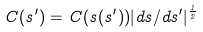Convert formula to latex. <formula><loc_0><loc_0><loc_500><loc_500>C ( s ^ { \prime } ) = C ( s ( s ^ { \prime } ) ) | d s / d s ^ { \prime } | ^ { \frac { 1 } { 2 } }</formula> 